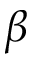Convert formula to latex. <formula><loc_0><loc_0><loc_500><loc_500>\beta</formula> 